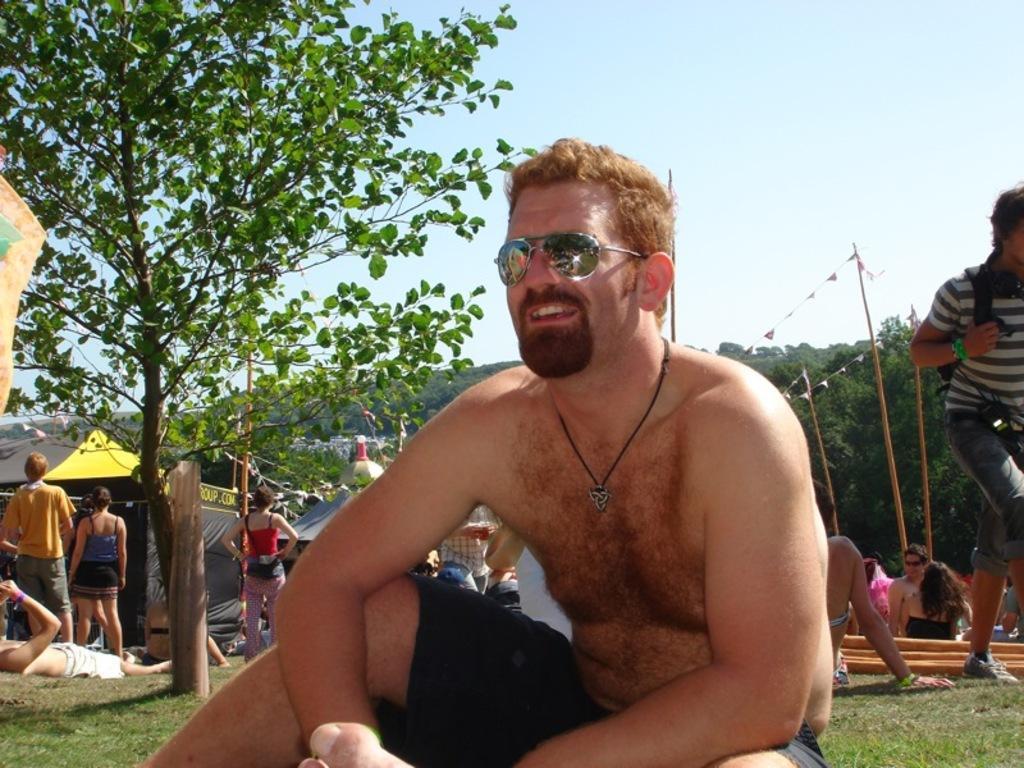Could you give a brief overview of what you see in this image? In this image in front there is a person. Behind him there are a few other people. There are tents. There are poles. In the background of the image there are trees and sky. 